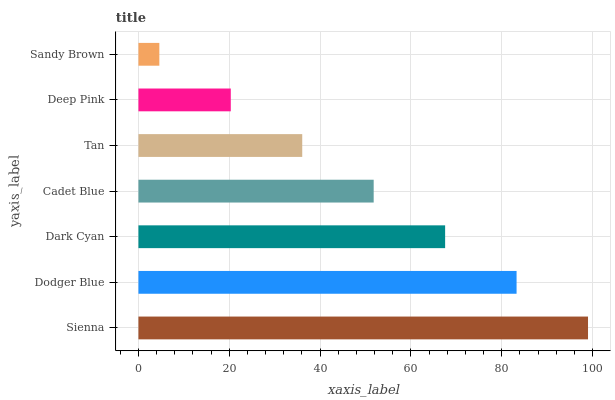Is Sandy Brown the minimum?
Answer yes or no. Yes. Is Sienna the maximum?
Answer yes or no. Yes. Is Dodger Blue the minimum?
Answer yes or no. No. Is Dodger Blue the maximum?
Answer yes or no. No. Is Sienna greater than Dodger Blue?
Answer yes or no. Yes. Is Dodger Blue less than Sienna?
Answer yes or no. Yes. Is Dodger Blue greater than Sienna?
Answer yes or no. No. Is Sienna less than Dodger Blue?
Answer yes or no. No. Is Cadet Blue the high median?
Answer yes or no. Yes. Is Cadet Blue the low median?
Answer yes or no. Yes. Is Sandy Brown the high median?
Answer yes or no. No. Is Deep Pink the low median?
Answer yes or no. No. 